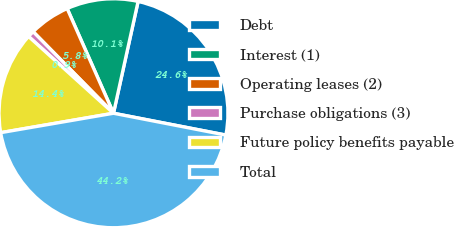Convert chart. <chart><loc_0><loc_0><loc_500><loc_500><pie_chart><fcel>Debt<fcel>Interest (1)<fcel>Operating leases (2)<fcel>Purchase obligations (3)<fcel>Future policy benefits payable<fcel>Total<nl><fcel>24.6%<fcel>10.08%<fcel>5.75%<fcel>0.92%<fcel>14.41%<fcel>44.23%<nl></chart> 